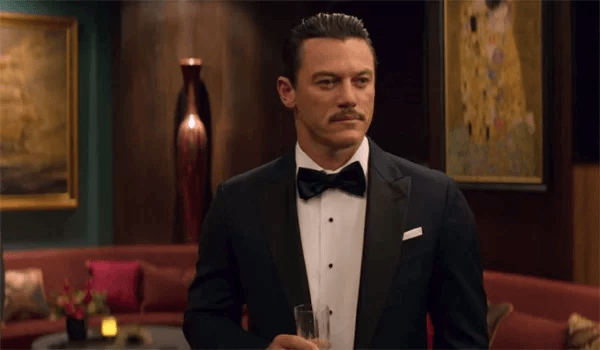What are the key elements in this picture? The image depicts a man in formal attire, wearing a black tuxedo with a white shirt and black bow tie, which conveys a sense of elegance and formality. He holds a glass, possibly containing champagne, enhancing the luxurious feel of the setting. The room has a rich, sophisticated decor with red walls and gold accents, adding to the overall opulent atmosphere. His expression is serious and focused, suggesting a moment of significant import or deep thought as he gazes off-camera. 